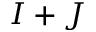<formula> <loc_0><loc_0><loc_500><loc_500>I + J</formula> 